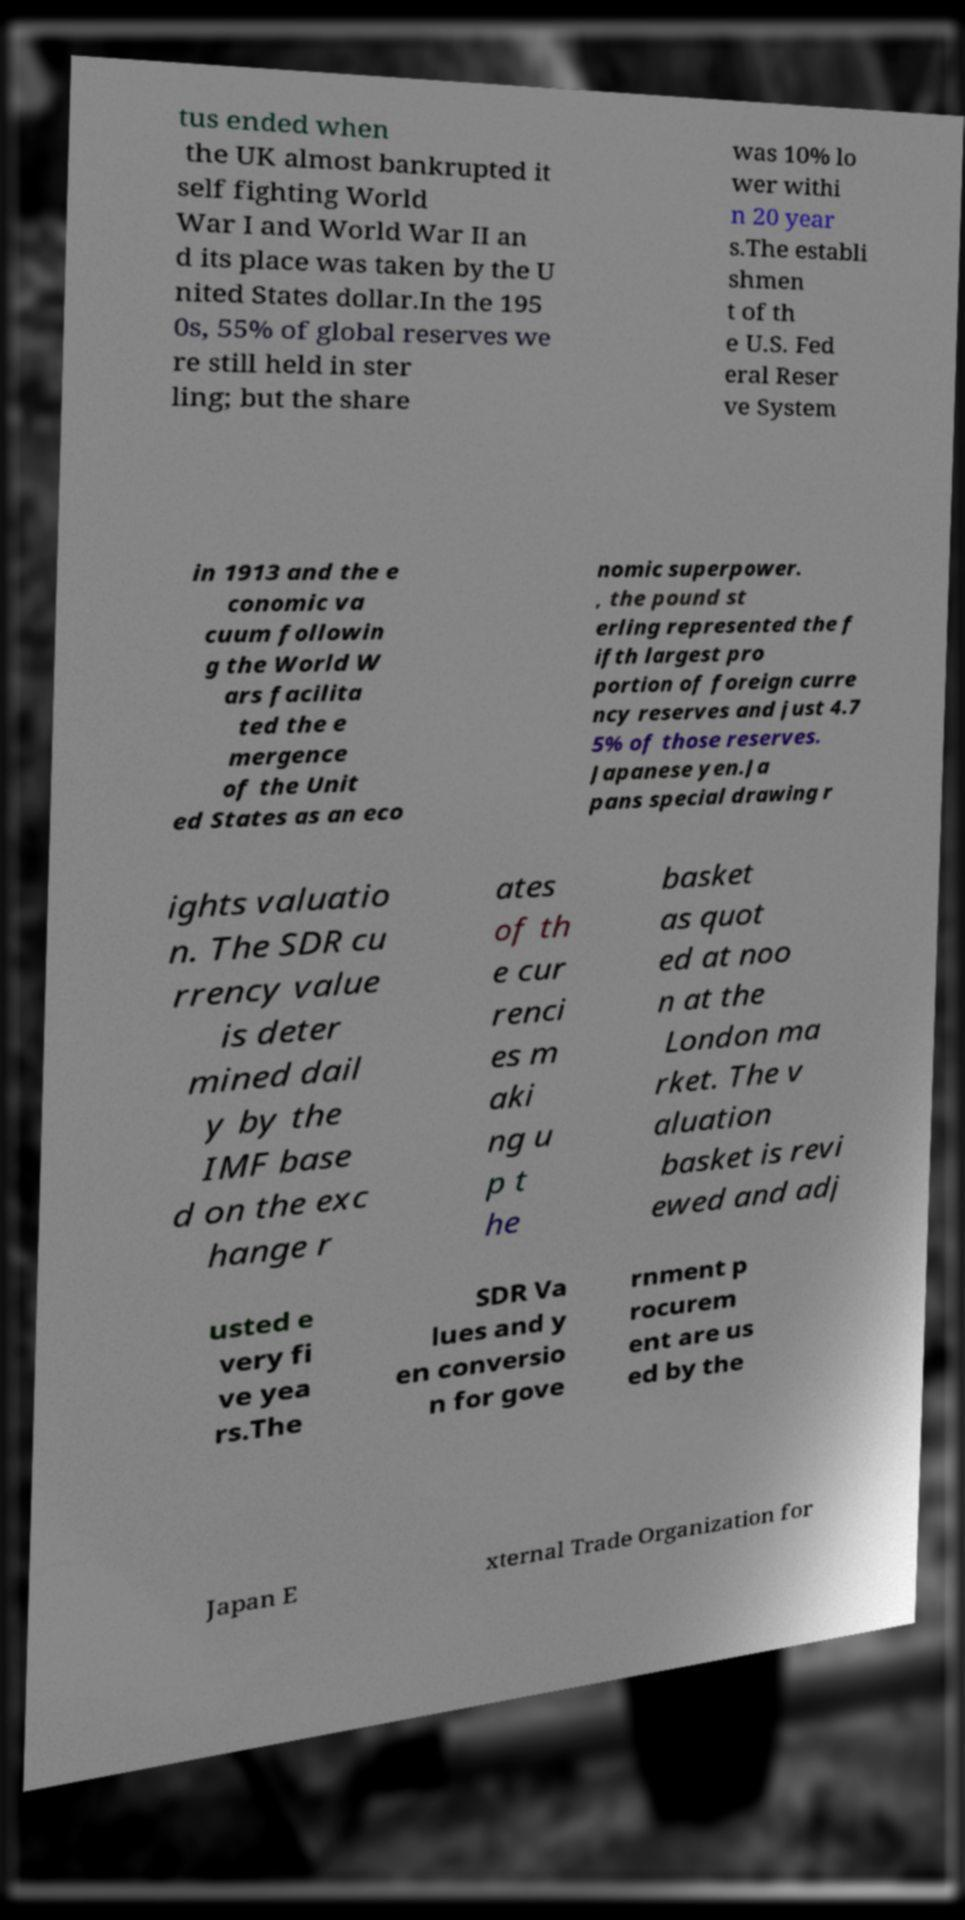Please identify and transcribe the text found in this image. tus ended when the UK almost bankrupted it self fighting World War I and World War II an d its place was taken by the U nited States dollar.In the 195 0s, 55% of global reserves we re still held in ster ling; but the share was 10% lo wer withi n 20 year s.The establi shmen t of th e U.S. Fed eral Reser ve System in 1913 and the e conomic va cuum followin g the World W ars facilita ted the e mergence of the Unit ed States as an eco nomic superpower. , the pound st erling represented the f ifth largest pro portion of foreign curre ncy reserves and just 4.7 5% of those reserves. Japanese yen.Ja pans special drawing r ights valuatio n. The SDR cu rrency value is deter mined dail y by the IMF base d on the exc hange r ates of th e cur renci es m aki ng u p t he basket as quot ed at noo n at the London ma rket. The v aluation basket is revi ewed and adj usted e very fi ve yea rs.The SDR Va lues and y en conversio n for gove rnment p rocurem ent are us ed by the Japan E xternal Trade Organization for 